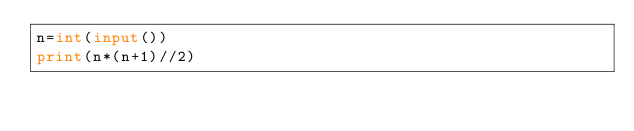<code> <loc_0><loc_0><loc_500><loc_500><_Python_>n=int(input())
print(n*(n+1)//2)</code> 